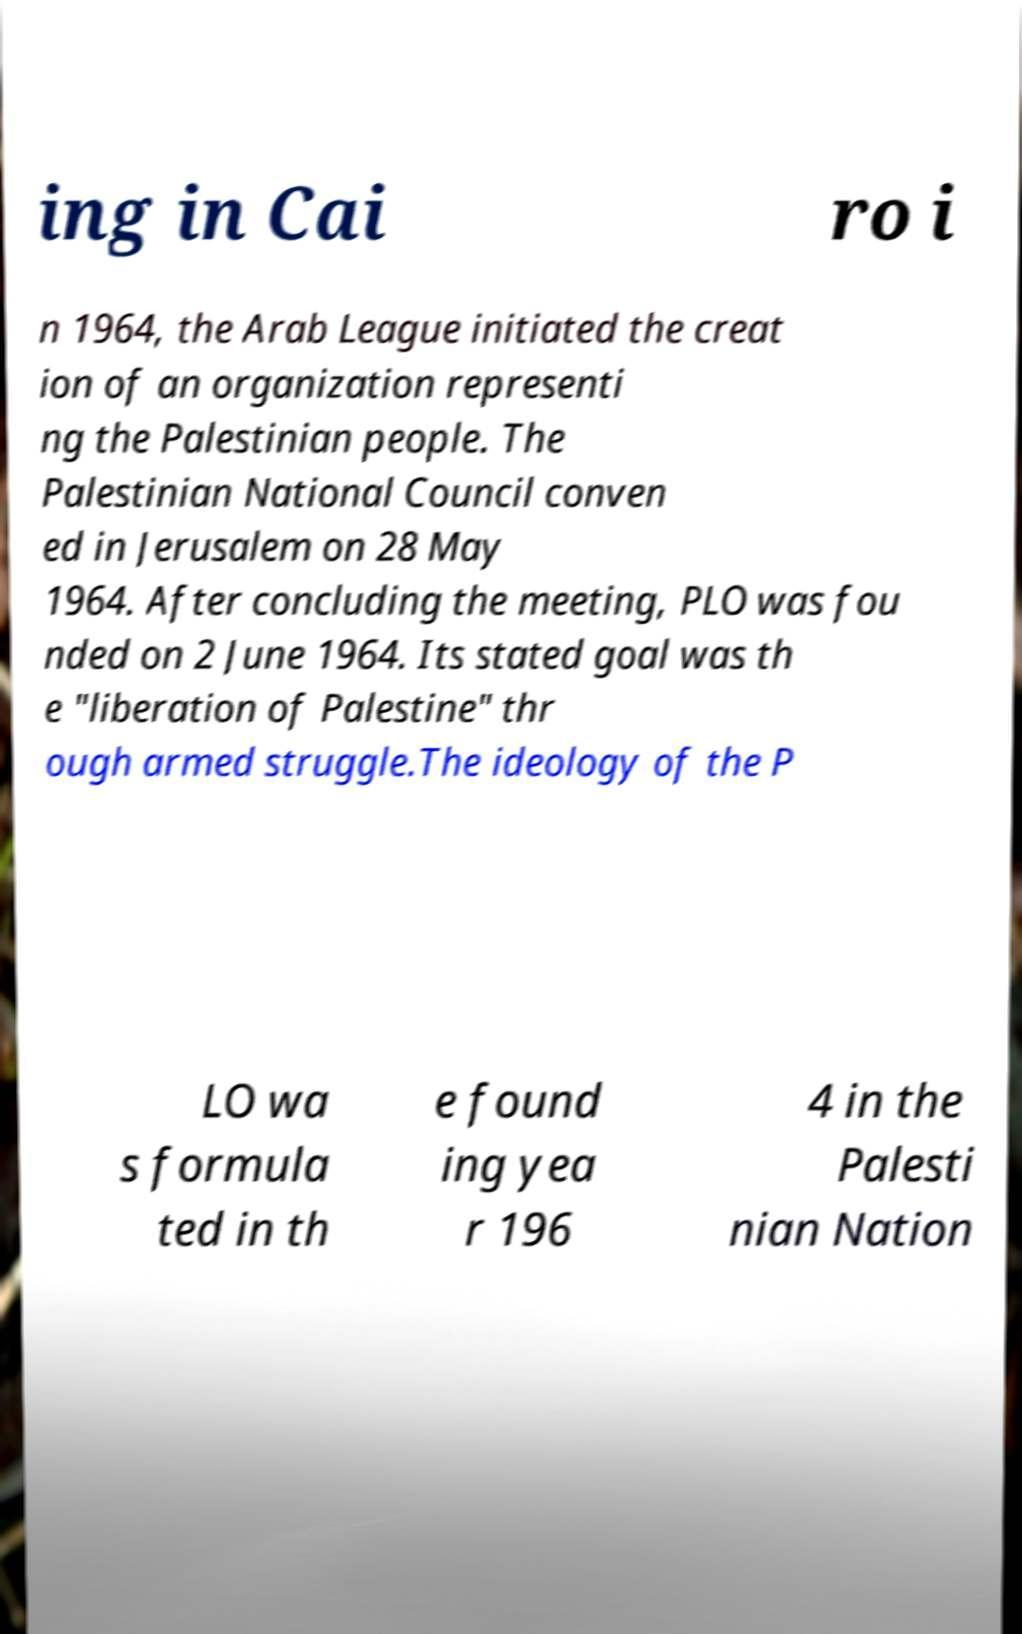For documentation purposes, I need the text within this image transcribed. Could you provide that? ing in Cai ro i n 1964, the Arab League initiated the creat ion of an organization representi ng the Palestinian people. The Palestinian National Council conven ed in Jerusalem on 28 May 1964. After concluding the meeting, PLO was fou nded on 2 June 1964. Its stated goal was th e "liberation of Palestine" thr ough armed struggle.The ideology of the P LO wa s formula ted in th e found ing yea r 196 4 in the Palesti nian Nation 